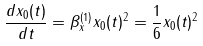Convert formula to latex. <formula><loc_0><loc_0><loc_500><loc_500>\frac { d x _ { 0 } ( t ) } { d t } = \beta _ { x } ^ { ( 1 ) } x _ { 0 } ( t ) ^ { 2 } = \frac { 1 } { 6 } x _ { 0 } ( t ) ^ { 2 }</formula> 